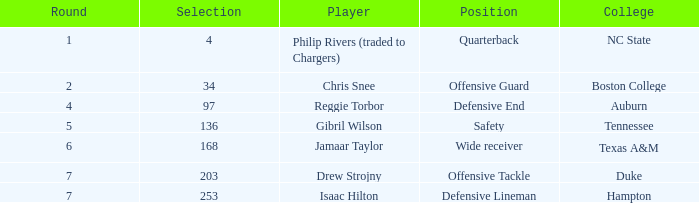Which Position has a Player of gibril wilson? Safety. 